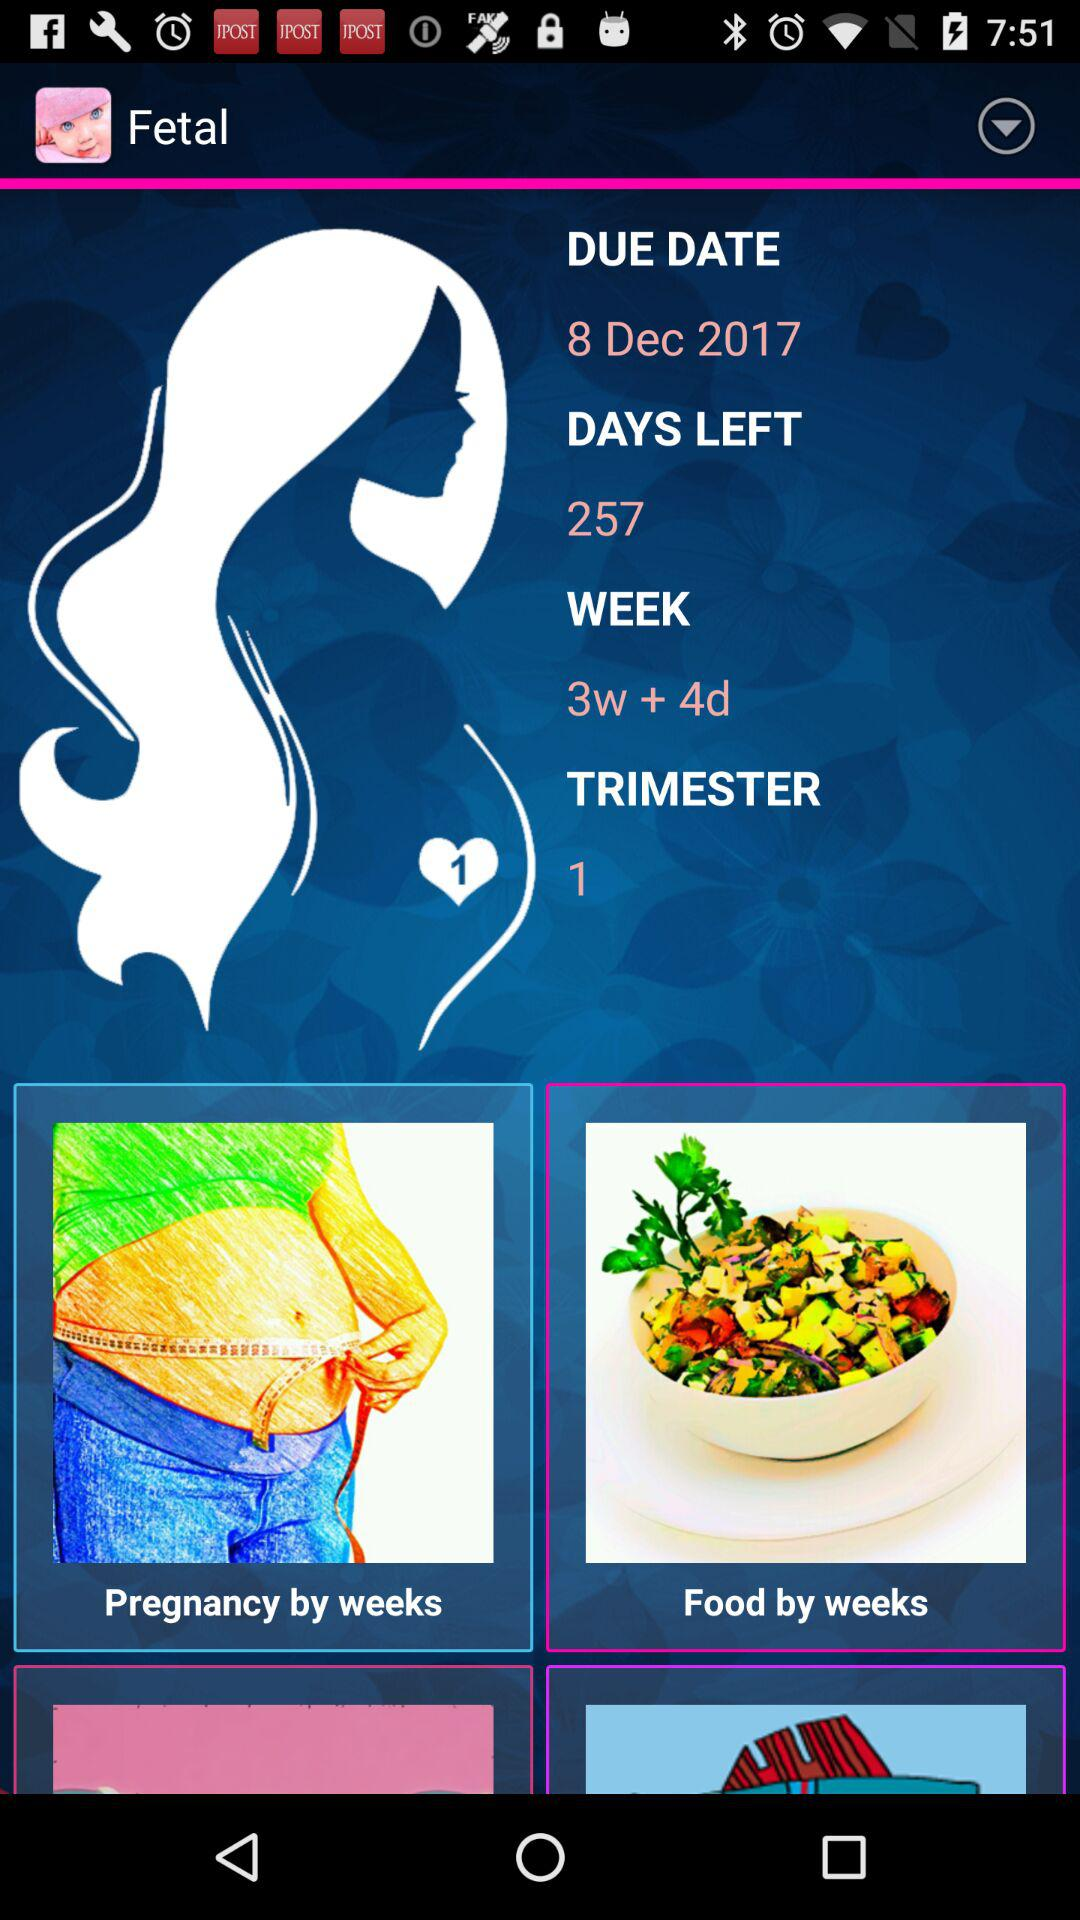What is the age of fetal? The age of the fetal is 3 weeks and 4 days. 